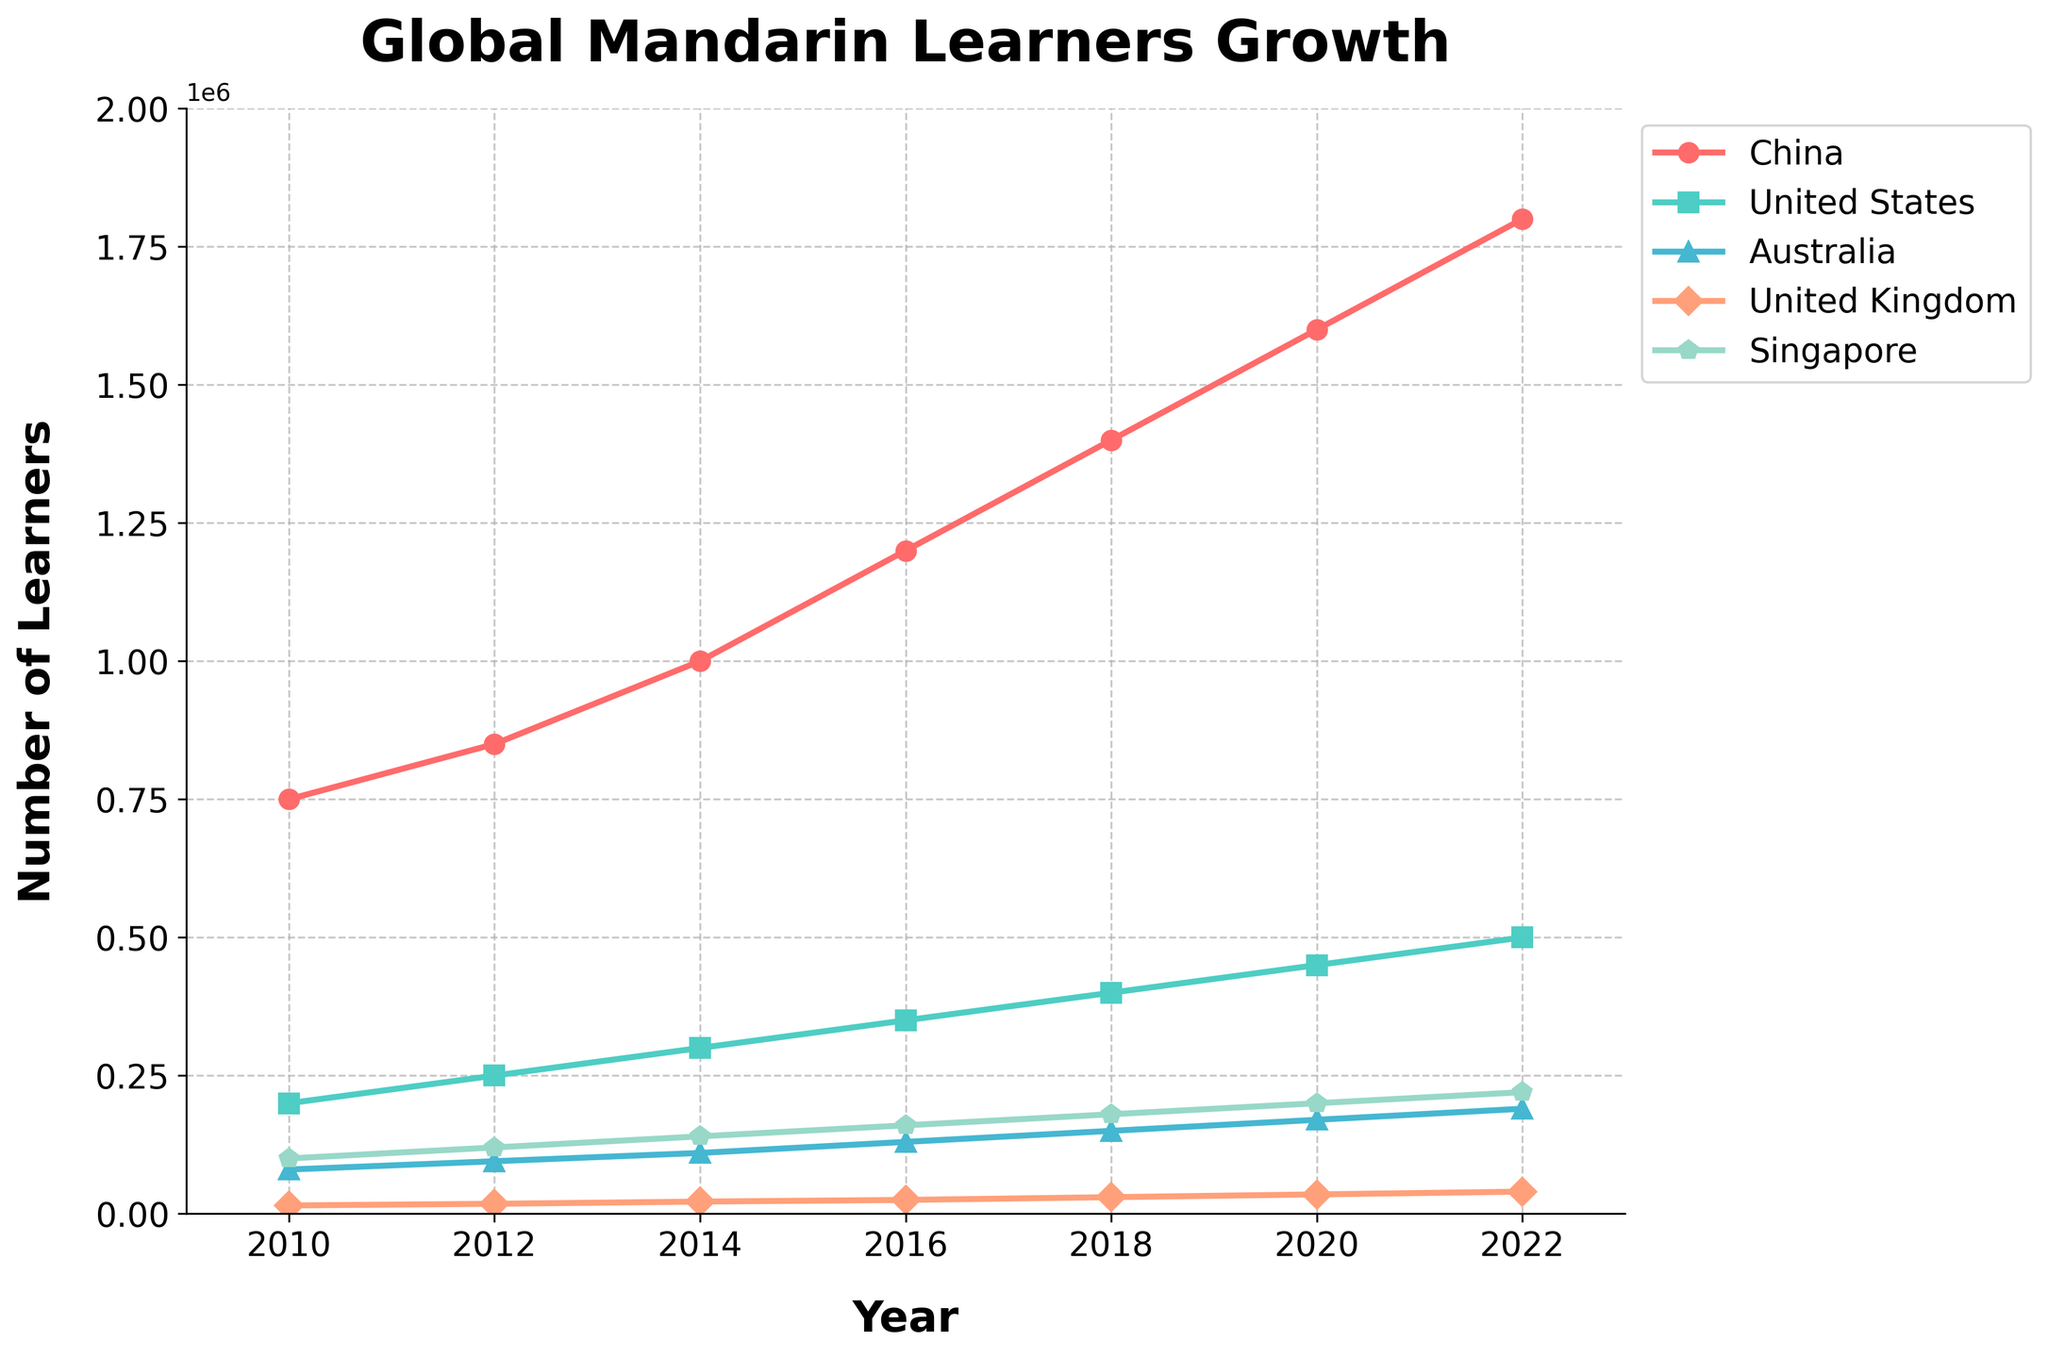What is the overall trend of Mandarin learners in China from 2010 to 2022? The number of learners in China consistently increased from 750,000 in 2010 to 1,800,000 in 2022, showing a steady upward trend.
Answer: Steady upward trend Which country experienced the highest increase in Mandarin learners from 2010 to 2022? Comparing the final and initial values for each country, China had the highest increase, from 750,000 in 2010 to 1,800,000 in 2022.
Answer: China Among United States, Australia, and Singapore, which had the least learners in 2020? By examining the 2020 data values on the chart, the United Kingdom had the least learners with 35,000.
Answer: United Kingdom What is the difference in the number of Mandarin learners between the United States and Australia in 2022? Subtracting the number of learners in Australia (190,000) from that in the United States (500,000) in 2022 gives 500,000 - 190,000 = 310,000.
Answer: 310,000 What was the average number of Mandarin learners in the United Kingdom across all years shown? Summing the numbers for the United Kingdom: 15,000, 18,000, 22,000, 25,000, 30,000, 35,000, 40,000. Then dividing by the number of data points: (15000+18000+22000+25000+30000+35000+40000)/7 = 25,714.
Answer: 25,714 Which country shows the second fastest growth rate from 2010 to 2022? By calculating growth rates ((value in 2022 - value in 2010)/value in 2010) for each country, the United States has a growth rate of (500,000-200,000)/200,000 = 1.5 or 150%. Singapore has a growth rate of (220,000-100,000)/100,000 = 1.2 or 120%. The United States is second fastest after China.
Answer: United States In which year did Mandarin learners in Australia surpass 100,000? The data for learners in Australia shows values surpassing 100,000 starting in 2014, as the value in 2012 was 95,000 and in 2014 it was 110,000.
Answer: 2014 How many countries had less than 200,000 Mandarin learners in 2022? From the chart, the United Kingdom (40,000) and Australia (190,000) had less than 200,000 learners in 2022.
Answer: 2 What was the combined total of Mandarin learners in China and Singapore in 2018? Summing the values for China (1,400,000) and Singapore (180,000) in 2018 gives 1,400,000 + 180,000 = 1,580,000.
Answer: 1,580,000 Based on the trend, which country shows more reliable exponential growth in Mandarin learners - the United States or Singapore? Both countries show growth, but the United States' growth (from 200,000 to 500,000) appears steadier and more consistent than Singapore's (from 100,000 to 220,000), implying more reliable exponential growth.
Answer: United States 